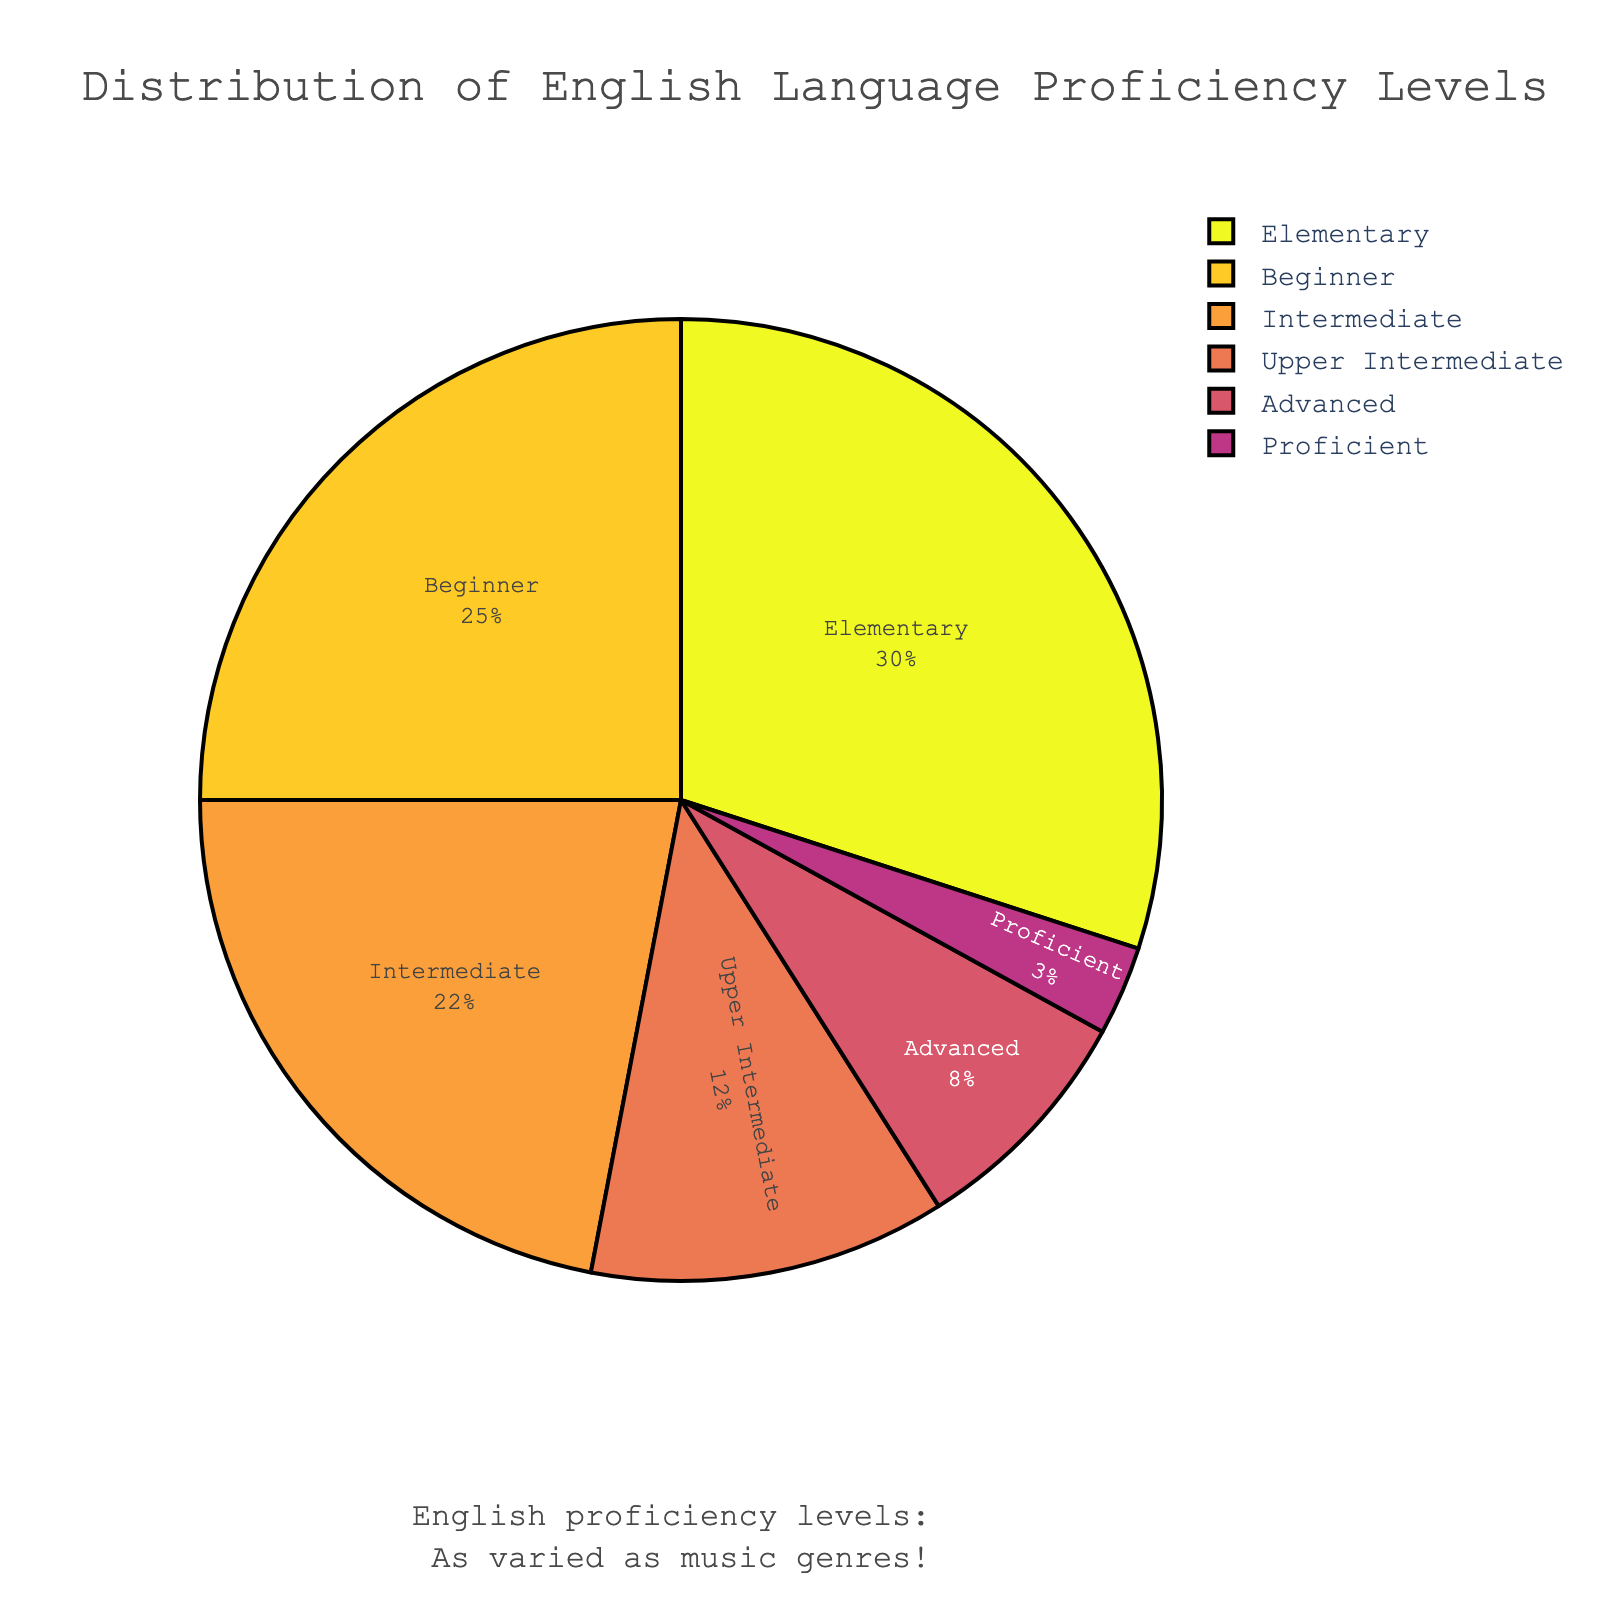What percentage of non-native speakers are at Advanced or Proficient levels combined? To find this, add the percentage of Advanced speakers (8%) to the percentage of Proficient speakers (3%). 8% + 3% = 11%
Answer: 11% Which proficiency level has the highest percentage of non-native speakers? Look at the pie chart and compare the size of the segments. The Elementary level has the largest segment with 30%.
Answer: Elementary How does the percentage of Intermediate speakers compare to Upper Intermediate speakers? Subtract the percentage of Upper Intermediate speakers (12%) from Intermediate speakers (22%). 22% - 12% = 10%. Intermediate speakers have 10% more.
Answer: Intermediate speakers have 10% more What is the combined percentage of Beginner and Elementary levels? Add the percentage of Beginner (25%) and Elementary (30%) levels. 25% + 30% = 55%.
Answer: 55% What percentage of non-native speakers are at least Intermediate level? Add the percentages of Intermediate (22%), Upper Intermediate (12%), Advanced (8%), and Proficient (3%) levels. 22% + 12% + 8% + 3% = 45%.
Answer: 45% Which proficiency level has the smallest percentage of non-native speakers? Look at the pie chart and identify the smallest segment. The Proficient level has the smallest segment with 3%.
Answer: Proficient How many more percentage points are there in the Elementary level compared to the Beginner level? Subtract the percentage of Beginner speakers (25%) from Elementary speakers (30%). 30% - 25% = 5%.
Answer: 5% What is the average percentage of the Upper Intermediate, Advanced, and Proficient levels? Add the percentages of Upper Intermediate (12%), Advanced (8%), and Proficient (3%) levels and divide by 3. (12% + 8% + 3%) / 3 = 7.67%.
Answer: 7.67% Is the percentage of speakers at the Intermediate level more than double the percentage of Advanced speakers? Compare twice the Advanced percentage (8% × 2 = 16%) to the Intermediate percentage (22%). Since 22% is greater than 16%, the Intermediate percentage is more than double.
Answer: Yes Which segment uses the darkest color and what is the proficiency level it represents? Observe the pie chart to identify the segment with the darkest color, which corresponds to the Elementary level.
Answer: Elementary 